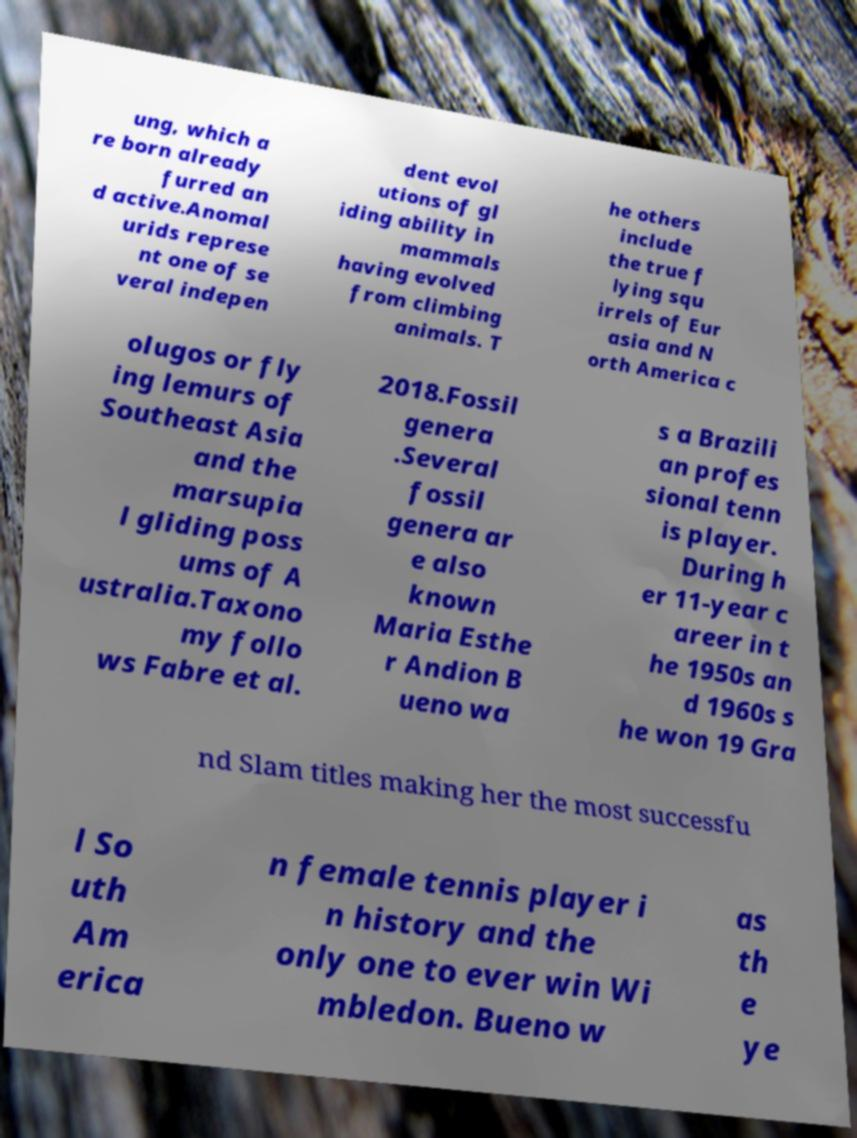Can you read and provide the text displayed in the image?This photo seems to have some interesting text. Can you extract and type it out for me? ung, which a re born already furred an d active.Anomal urids represe nt one of se veral indepen dent evol utions of gl iding ability in mammals having evolved from climbing animals. T he others include the true f lying squ irrels of Eur asia and N orth America c olugos or fly ing lemurs of Southeast Asia and the marsupia l gliding poss ums of A ustralia.Taxono my follo ws Fabre et al. 2018.Fossil genera .Several fossil genera ar e also known Maria Esthe r Andion B ueno wa s a Brazili an profes sional tenn is player. During h er 11-year c areer in t he 1950s an d 1960s s he won 19 Gra nd Slam titles making her the most successfu l So uth Am erica n female tennis player i n history and the only one to ever win Wi mbledon. Bueno w as th e ye 